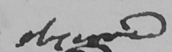Please transcribe the handwritten text in this image. observed 